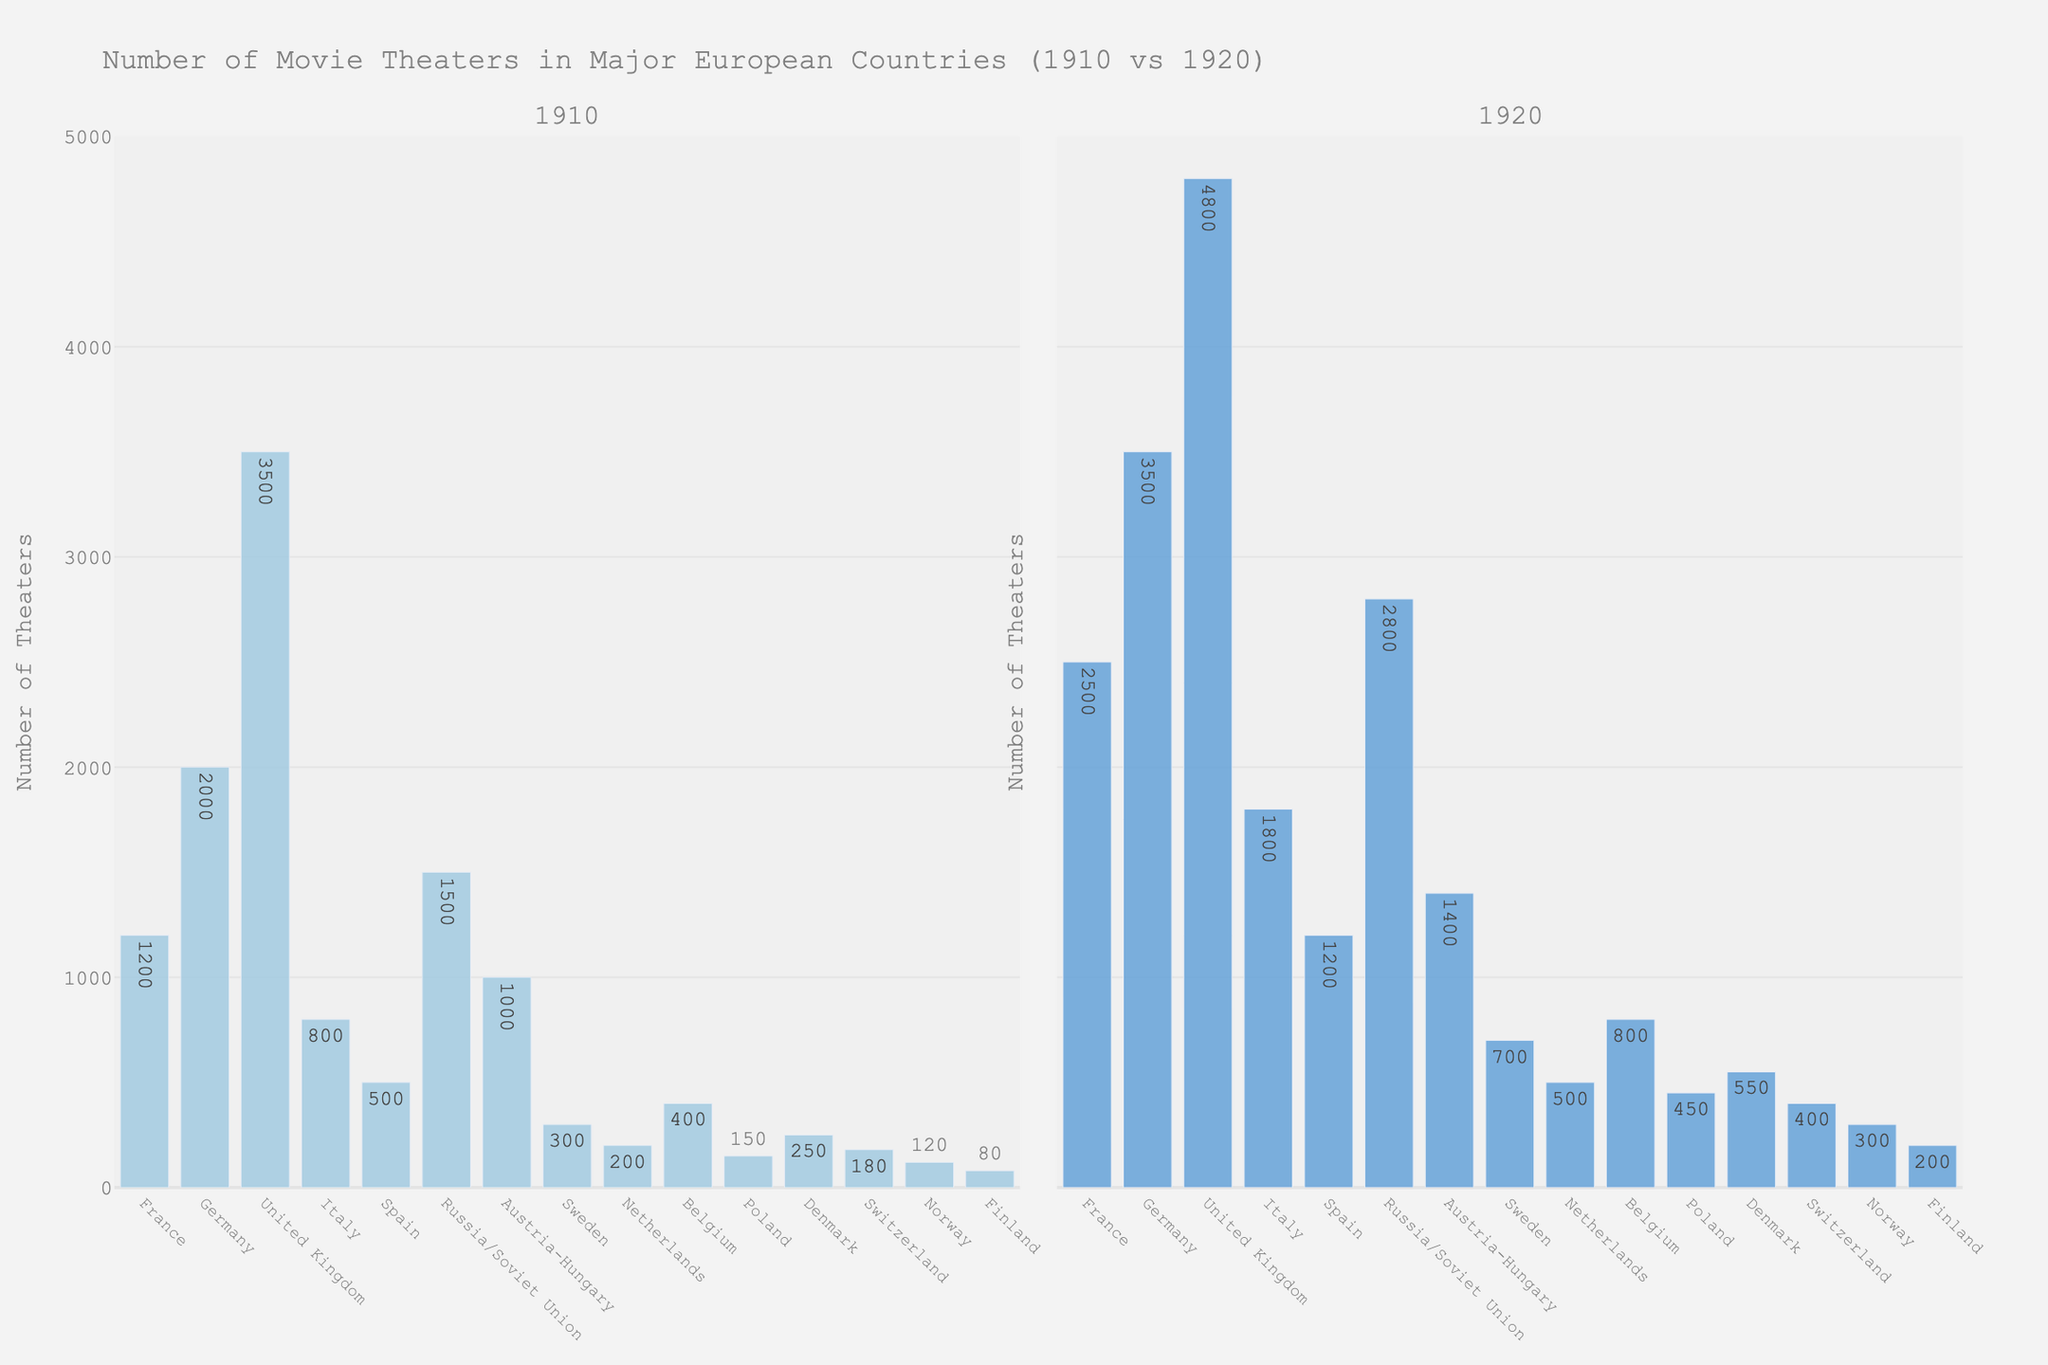Which country had the largest number of movie theaters in 1920? The tallest bar in the 1920 subplot corresponds to the United Kingdom, which had 4,800 theaters.
Answer: United Kingdom How many more theaters did France have in 1920 compared to 1910? France had 2,500 theaters in 1920 and 1,200 theaters in 1910. The difference is 2,500 - 1,200 = 1,300.
Answer: 1,300 Which country had the smallest number of theaters in 1910, and how does it compare to 1920? Finland had the smallest number of theaters in 1910 with 80. In 1920, Finland had 200 theaters, which is 120 more than in 1910.
Answer: Finland, 120 more What is the total number of theaters in Italy and Spain in 1920? Italy had 1,800 theaters and Spain had 1,200 theaters in 1920. The total is 1,800 + 1,200 = 3,000.
Answer: 3,000 In which year did Germany have more theaters, 1910 or 1920, and by how many? Germany had 2,000 theaters in 1910 and 3,500 theaters in 1920. The difference is 3,500 - 2,000 = 1,500.
Answer: 1920, 1,500 more Which two countries showed the least change in the number of theaters from 1910 to 1920? By comparing the heights of the bars, Austria-Hungary (400 increase) and Belgium (400 increase) showed the least change, both gaining 400 theaters from 1910 to 1920.
Answer: Austria-Hungary and Belgium How did the number of theaters in the Soviet Union (Russia/Soviet Union) change from 1910 to 1920? The number of theaters in the Soviet Union increased from 1,500 in 1910 to 2,800 in 1920, which is an increase of 2,800 - 1,500 = 1,300.
Answer: Increased by 1,300 Which country experienced the highest percentage increase in the number of theaters from 1910 to 1920? Calculate the percentage increase for each country: 
\[ 
(1) France: \left(\frac{2500-1200}{1200}\right) \times 100 \approx 108.33\% \\
(2) Germany: \left(\frac{3500-2000}{2000}\right) \times 100 \approx 75\% \\
(3) United Kingdom: \left(\frac{4800-3500}{3500}\right) \times 100 \approx 37.14\% \\
(4) Italy: \left(\frac{1800-800}{800}\right) \times 100 = 125\% \\
(5) Spain: \left(\frac{1200-500}{500}\right) \times 100 = 140\%
\]
Spain had the highest percentage increase, approx 140%.
Answer: Spain What is the combined number of theaters for all countries in 1910? Sum the number of theaters for all countries in 1910: 1200 + 2000 + 3500 + 800 + 500 + 1500 + 1000 + 300 + 200 + 400 + 150 + 250 + 180 + 120 + 80 = 12180.
Answer: 12,180 Which country's number of theaters doubled from 1910 to 1920? France had 1,200 theaters in 1910 and exactly doubled to 2,500 in 1920.
Answer: France 